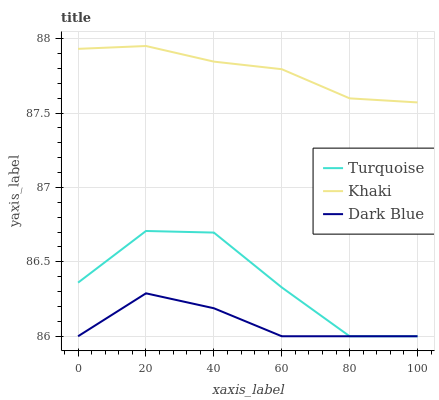Does Turquoise have the minimum area under the curve?
Answer yes or no. No. Does Turquoise have the maximum area under the curve?
Answer yes or no. No. Is Turquoise the smoothest?
Answer yes or no. No. Is Khaki the roughest?
Answer yes or no. No. Does Khaki have the lowest value?
Answer yes or no. No. Does Turquoise have the highest value?
Answer yes or no. No. Is Turquoise less than Khaki?
Answer yes or no. Yes. Is Khaki greater than Dark Blue?
Answer yes or no. Yes. Does Turquoise intersect Khaki?
Answer yes or no. No. 